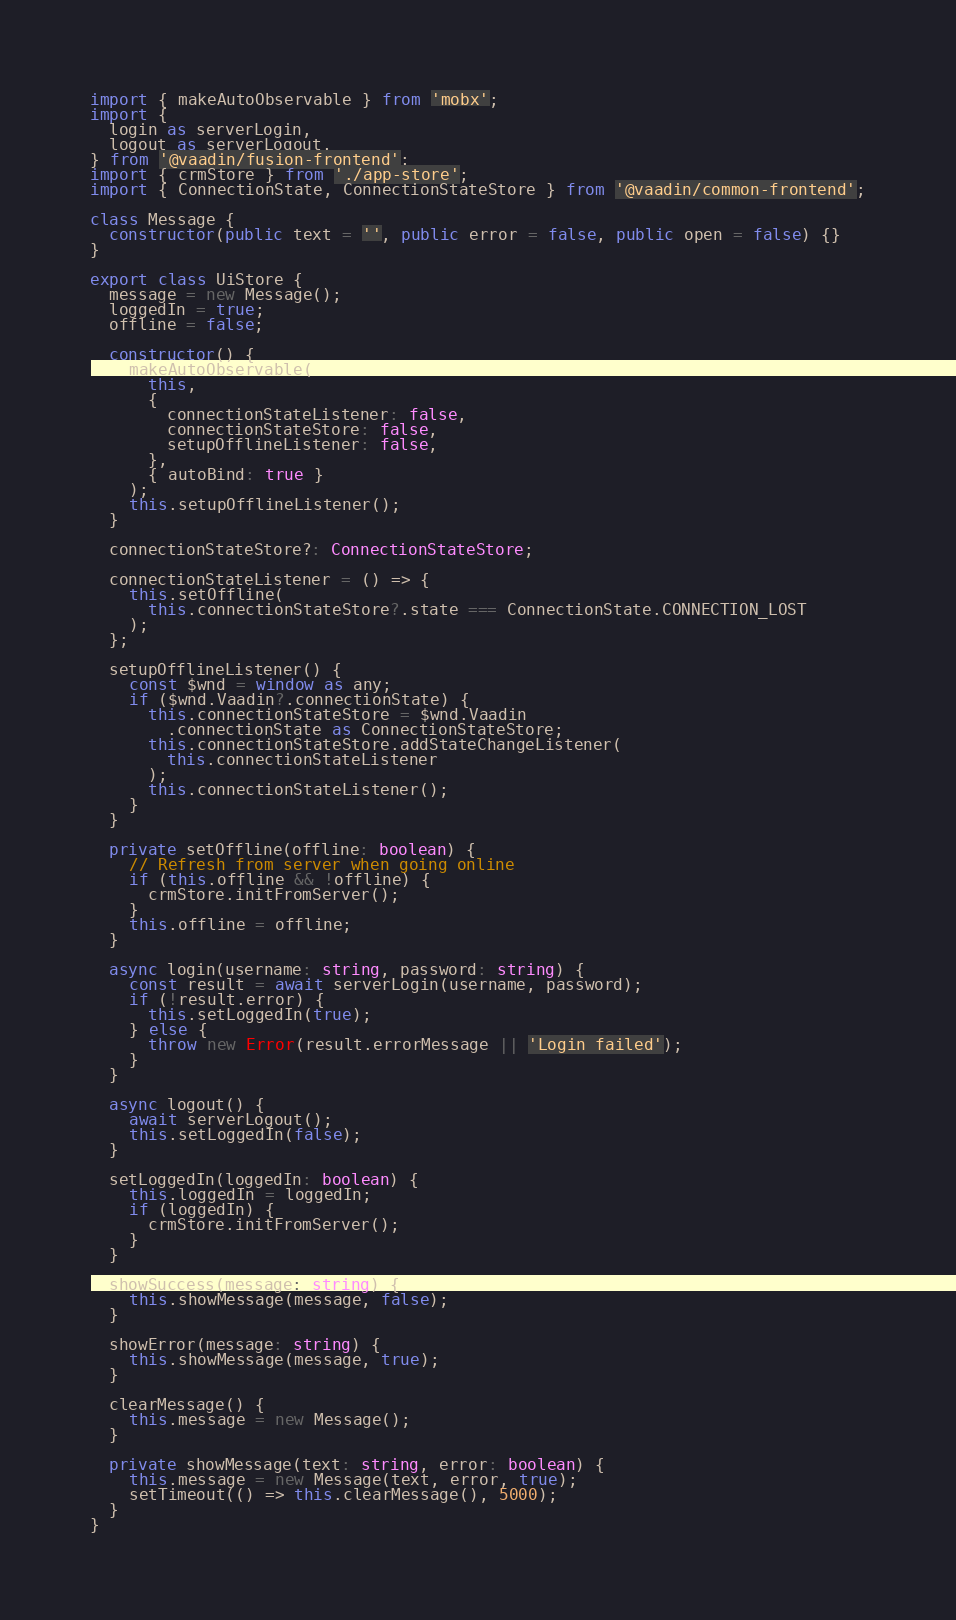Convert code to text. <code><loc_0><loc_0><loc_500><loc_500><_TypeScript_>import { makeAutoObservable } from 'mobx';
import {
  login as serverLogin,
  logout as serverLogout,
} from '@vaadin/fusion-frontend';
import { crmStore } from './app-store';
import { ConnectionState, ConnectionStateStore } from '@vaadin/common-frontend';

class Message {
  constructor(public text = '', public error = false, public open = false) {}
}

export class UiStore {
  message = new Message();
  loggedIn = true;
  offline = false;

  constructor() {
    makeAutoObservable(
      this,
      {
        connectionStateListener: false,
        connectionStateStore: false,
        setupOfflineListener: false,
      },
      { autoBind: true }
    );
    this.setupOfflineListener();
  }

  connectionStateStore?: ConnectionStateStore;

  connectionStateListener = () => {
    this.setOffline(
      this.connectionStateStore?.state === ConnectionState.CONNECTION_LOST
    );
  };

  setupOfflineListener() {
    const $wnd = window as any;
    if ($wnd.Vaadin?.connectionState) {
      this.connectionStateStore = $wnd.Vaadin
        .connectionState as ConnectionStateStore;
      this.connectionStateStore.addStateChangeListener(
        this.connectionStateListener
      );
      this.connectionStateListener();
    }
  }

  private setOffline(offline: boolean) {
    // Refresh from server when going online
    if (this.offline && !offline) {
      crmStore.initFromServer();
    }
    this.offline = offline;
  }

  async login(username: string, password: string) {
    const result = await serverLogin(username, password);
    if (!result.error) {
      this.setLoggedIn(true);
    } else {
      throw new Error(result.errorMessage || 'Login failed');
    }
  }

  async logout() {
    await serverLogout();
    this.setLoggedIn(false);
  }

  setLoggedIn(loggedIn: boolean) {
    this.loggedIn = loggedIn;
    if (loggedIn) {
      crmStore.initFromServer();
    }
  }

  showSuccess(message: string) {
    this.showMessage(message, false);
  }

  showError(message: string) {
    this.showMessage(message, true);
  }

  clearMessage() {
    this.message = new Message();
  }

  private showMessage(text: string, error: boolean) {
    this.message = new Message(text, error, true);
    setTimeout(() => this.clearMessage(), 5000);
  }
}
</code> 